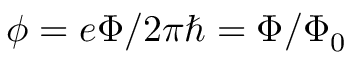<formula> <loc_0><loc_0><loc_500><loc_500>\phi = e \Phi / 2 \pi \hbar { = } \Phi / \Phi _ { 0 }</formula> 